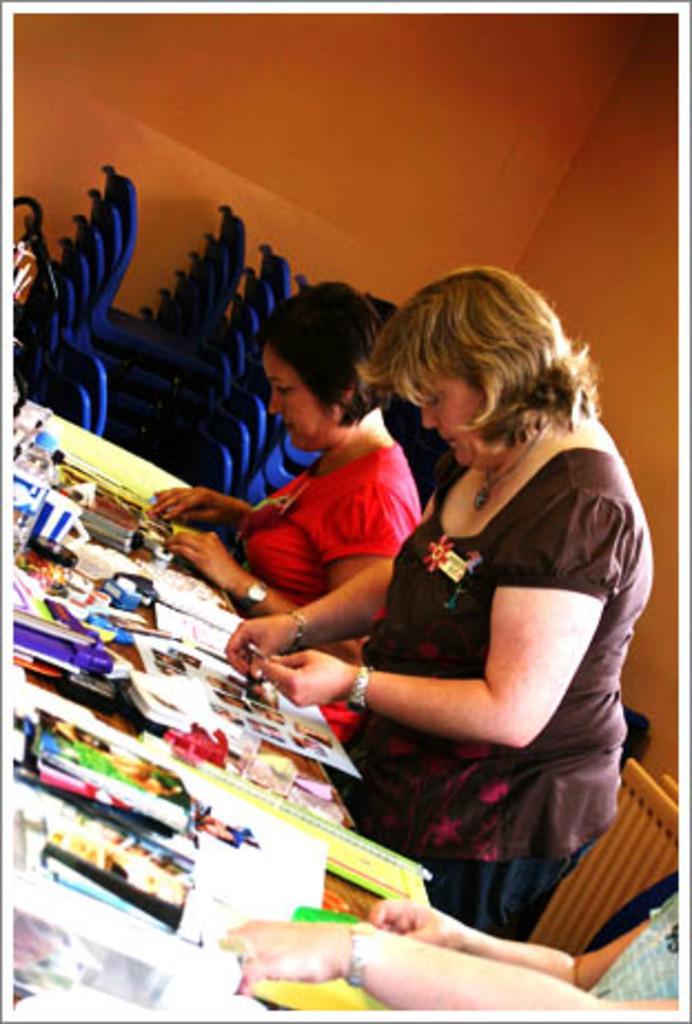Can you describe this image briefly? This image is taken indoors. In the background there is a wall and there are many empty chairs. At the bottom of the image there is a table with a few books, papers, a bottle, a cup and many things on it. On the right side of the image two women are sitting on the chairs and a woman is standing and holding a photo in her hand. 